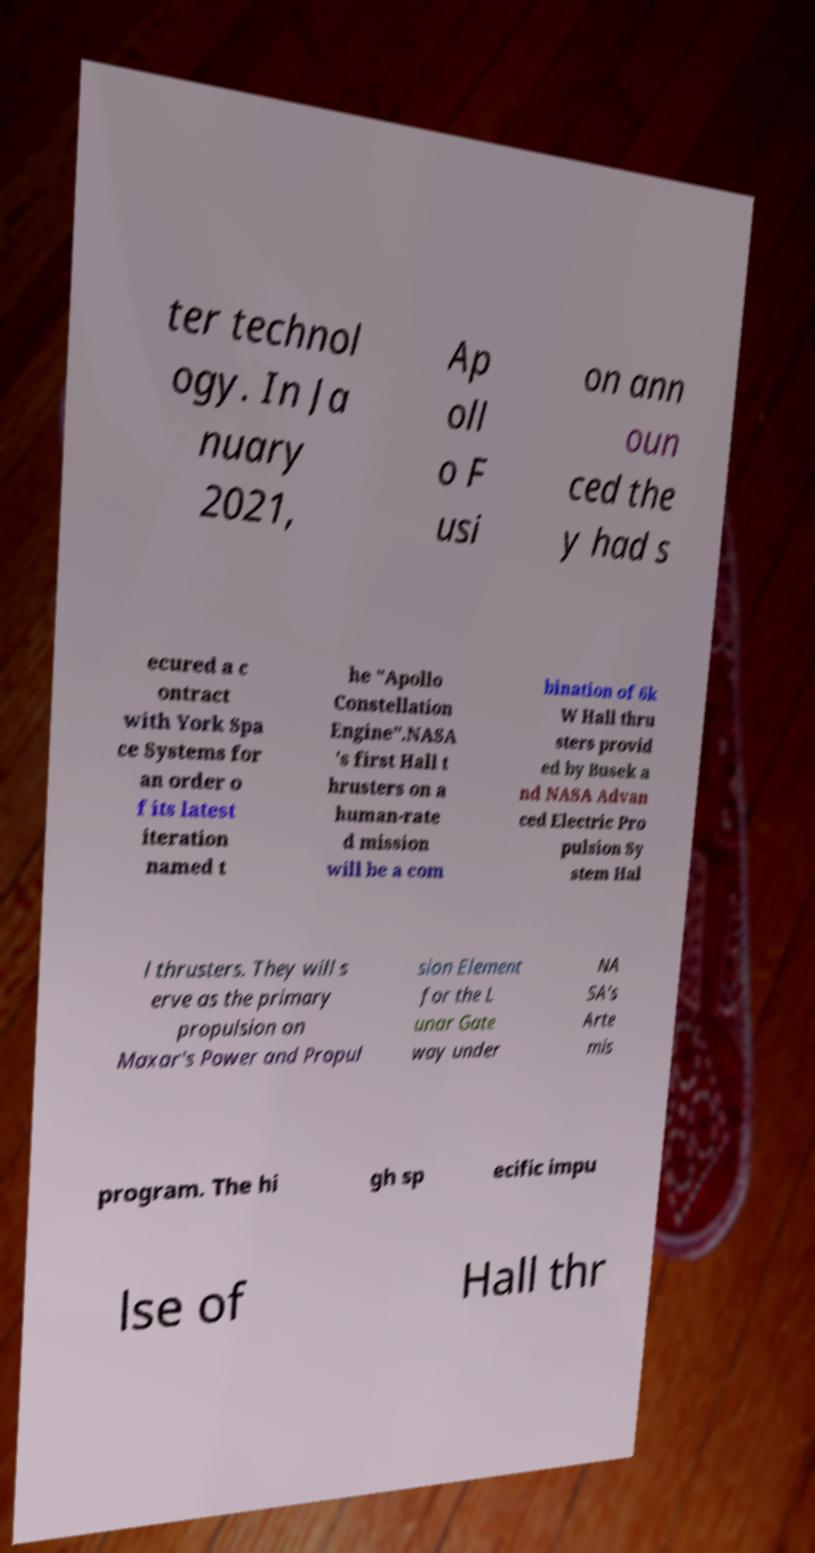For documentation purposes, I need the text within this image transcribed. Could you provide that? ter technol ogy. In Ja nuary 2021, Ap oll o F usi on ann oun ced the y had s ecured a c ontract with York Spa ce Systems for an order o f its latest iteration named t he "Apollo Constellation Engine".NASA 's first Hall t hrusters on a human-rate d mission will be a com bination of 6k W Hall thru sters provid ed by Busek a nd NASA Advan ced Electric Pro pulsion Sy stem Hal l thrusters. They will s erve as the primary propulsion on Maxar's Power and Propul sion Element for the L unar Gate way under NA SA's Arte mis program. The hi gh sp ecific impu lse of Hall thr 